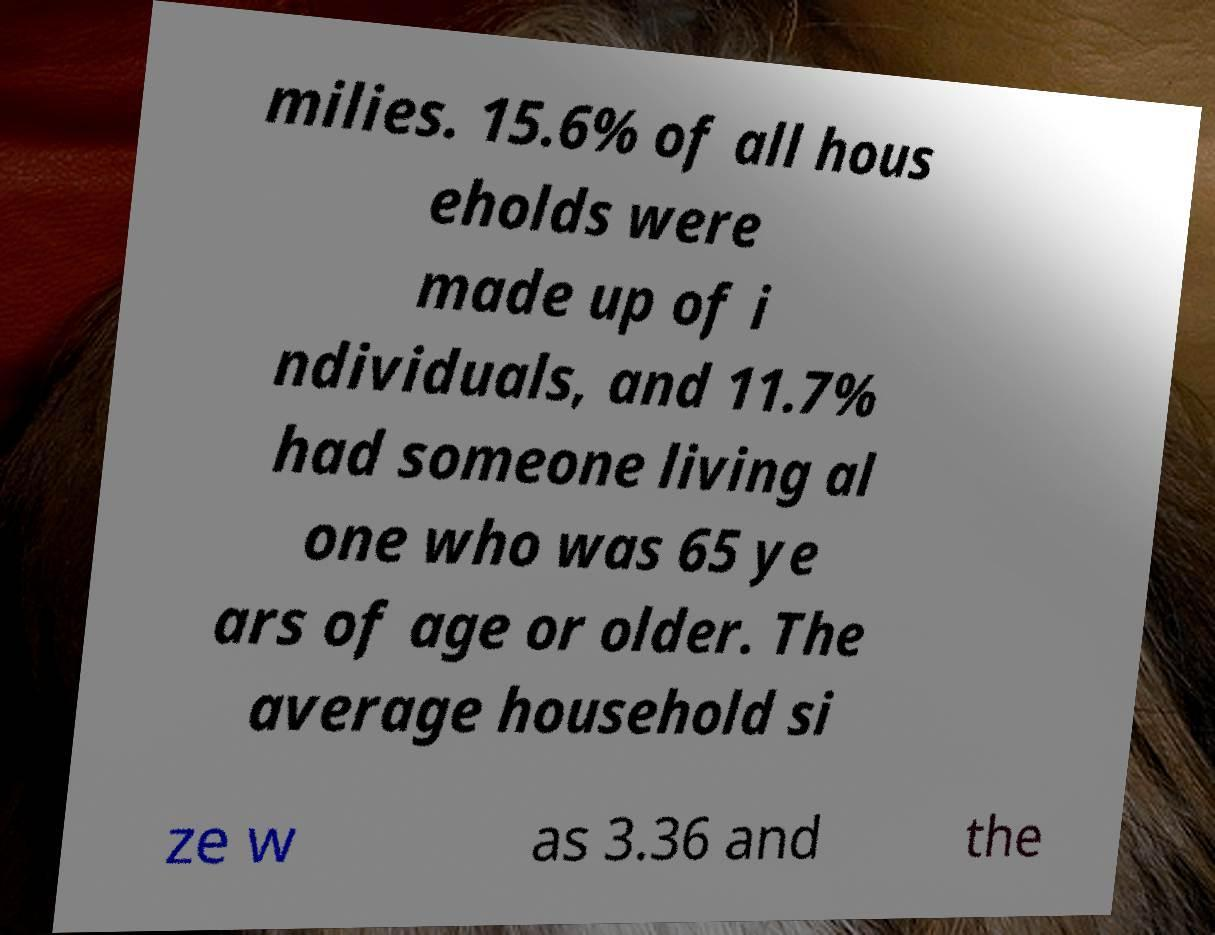I need the written content from this picture converted into text. Can you do that? milies. 15.6% of all hous eholds were made up of i ndividuals, and 11.7% had someone living al one who was 65 ye ars of age or older. The average household si ze w as 3.36 and the 